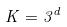Convert formula to latex. <formula><loc_0><loc_0><loc_500><loc_500>K = 3 ^ { d }</formula> 